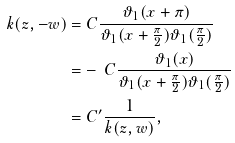<formula> <loc_0><loc_0><loc_500><loc_500>k ( z , - w ) = & \ C \frac { \vartheta _ { 1 } ( x + \pi ) } { \vartheta _ { 1 } ( x + \frac { \pi } { 2 } ) \vartheta _ { 1 } ( \frac { \pi } { 2 } ) } \\ = & - \ C \frac { \vartheta _ { 1 } ( x ) } { \vartheta _ { 1 } ( x + \frac { \pi } { 2 } ) \vartheta _ { 1 } ( \frac { \pi } { 2 } ) } \\ = & \ C ^ { \prime } \frac { 1 } { k ( z , w ) } ,</formula> 